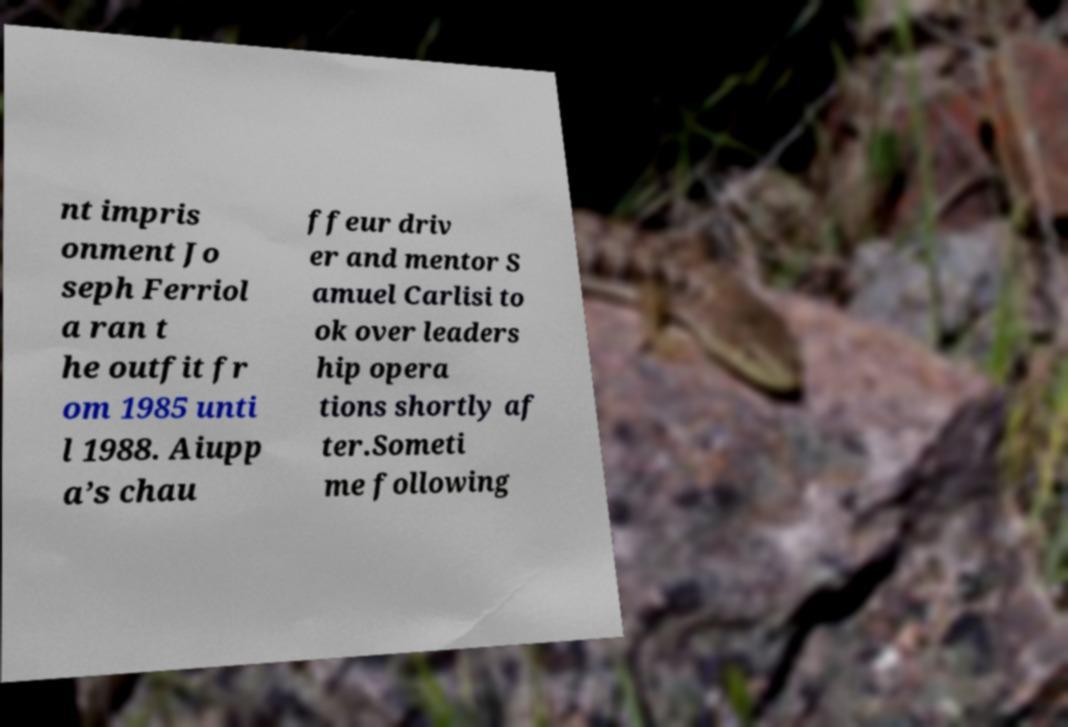For documentation purposes, I need the text within this image transcribed. Could you provide that? nt impris onment Jo seph Ferriol a ran t he outfit fr om 1985 unti l 1988. Aiupp a’s chau ffeur driv er and mentor S amuel Carlisi to ok over leaders hip opera tions shortly af ter.Someti me following 